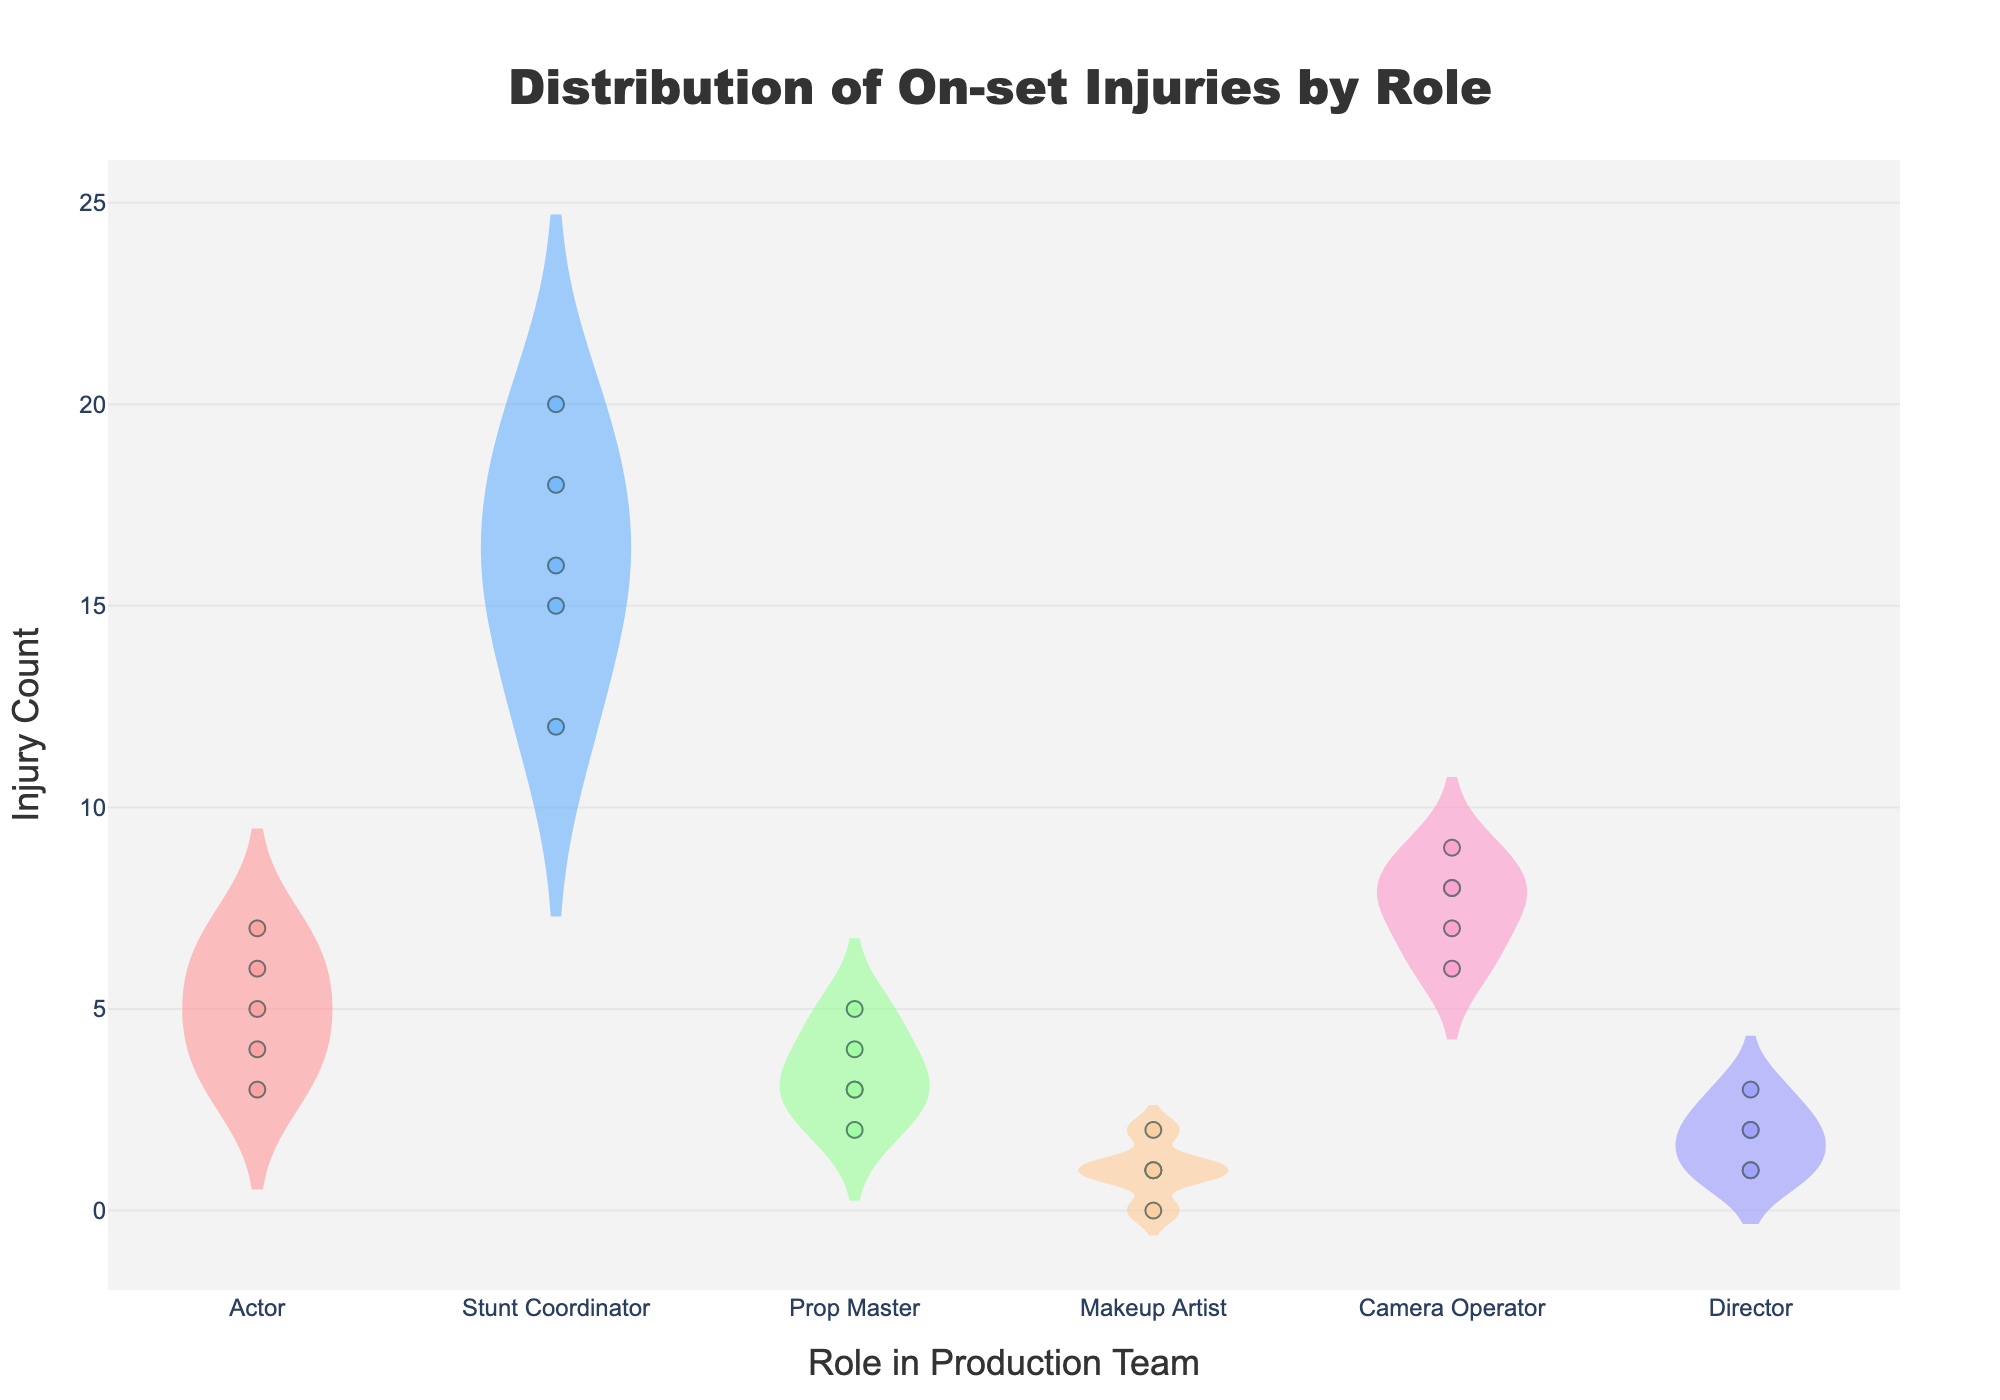What is the title of the plot? The title can be identified at the top of the figure. It is normally displayed in a larger and bolder font for prominence.
Answer: Distribution of On-set Injuries by Role Which role has the highest average injury count? To identify the role with the highest average injury count, we need to compare the center lines of the violin plots, which represent the mean injury count for each role.
Answer: Stunt Coordinator How many unique roles are represented in the plot? Count the number of distinct names on the x-axis representing different roles in the production team.
Answer: 6 What is the minimum injury count observed for the Makeup Artist role? Examine the lower boundary of the jittered points or the bottom part of the violin plot for the Makeup Artist role.
Answer: 0 Compare the injury counts of Actors and Directors. Which role has a higher maximum injury count? Identify the highest jittered points or the top edge of the violin plots for both Actors and Directors, and then compare them.
Answer: Actor What is the range of injury counts for the Camera Operator role? The range is found by subtracting the smallest injury count from the largest injury count visible in the jittered points for the Camera Operator role.
Answer: 3 (9 - 6 = 3) Among the roles listed, which role has the most spread in injury counts? The spread within the violin plot can be identified by the width and vertical length of the plot. The role with the most spread will have a taller and broader plot.
Answer: Stunt Coordinator What is the median injury count for the Prop Master role? Locate the midpoint line in the violin plot for the Prop Master. The line in the middle of the violin plot represents the median.
Answer: 3 How does the distribution of injuries for Makeup Artists compare to that for Camera Operators? Examine the overall shape and spread of the violin plots for both roles. The Makeup Artist plot is narrower and closer to zero, while the Camera Operator plot is wider and more spread out.
Answer: Camera Operators have a wider distribution and higher counts What is the most frequent injury count for the Director role? The most frequent count is often at the widest part of the violin plot or represented by multiple jittered points clustering together at a specific value.
Answer: 2 